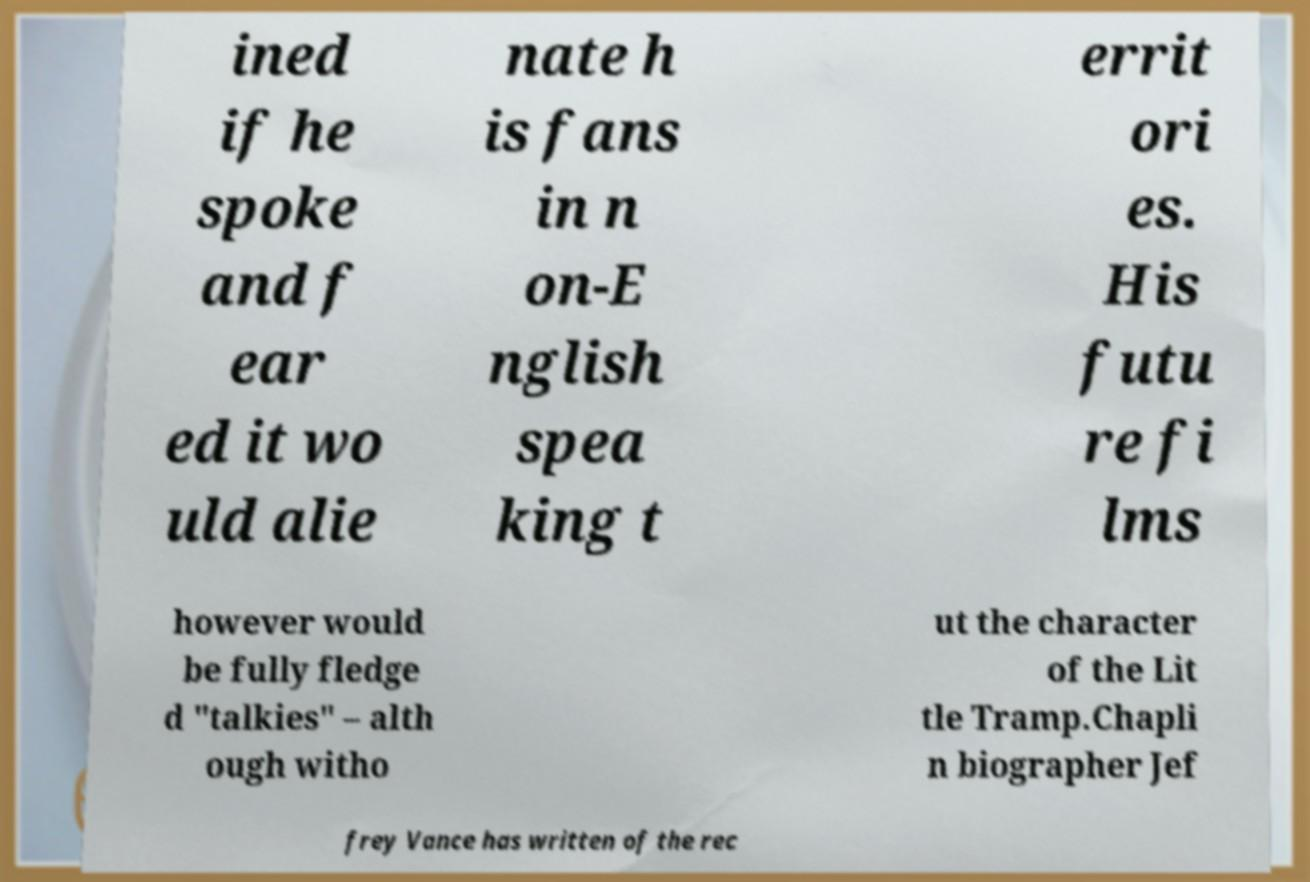Could you assist in decoding the text presented in this image and type it out clearly? ined if he spoke and f ear ed it wo uld alie nate h is fans in n on-E nglish spea king t errit ori es. His futu re fi lms however would be fully fledge d "talkies" – alth ough witho ut the character of the Lit tle Tramp.Chapli n biographer Jef frey Vance has written of the rec 